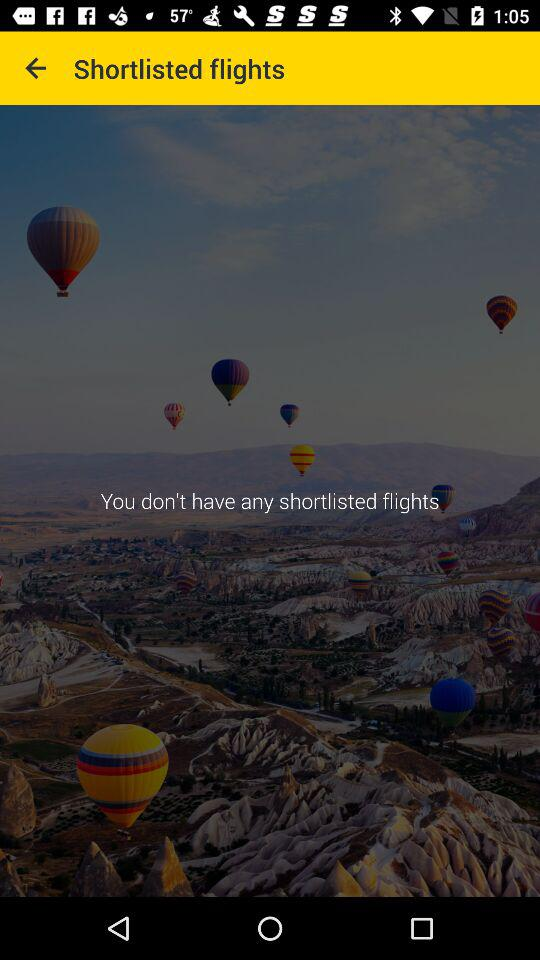How many shortlisted flights are there? There are no shortlisted flights. 